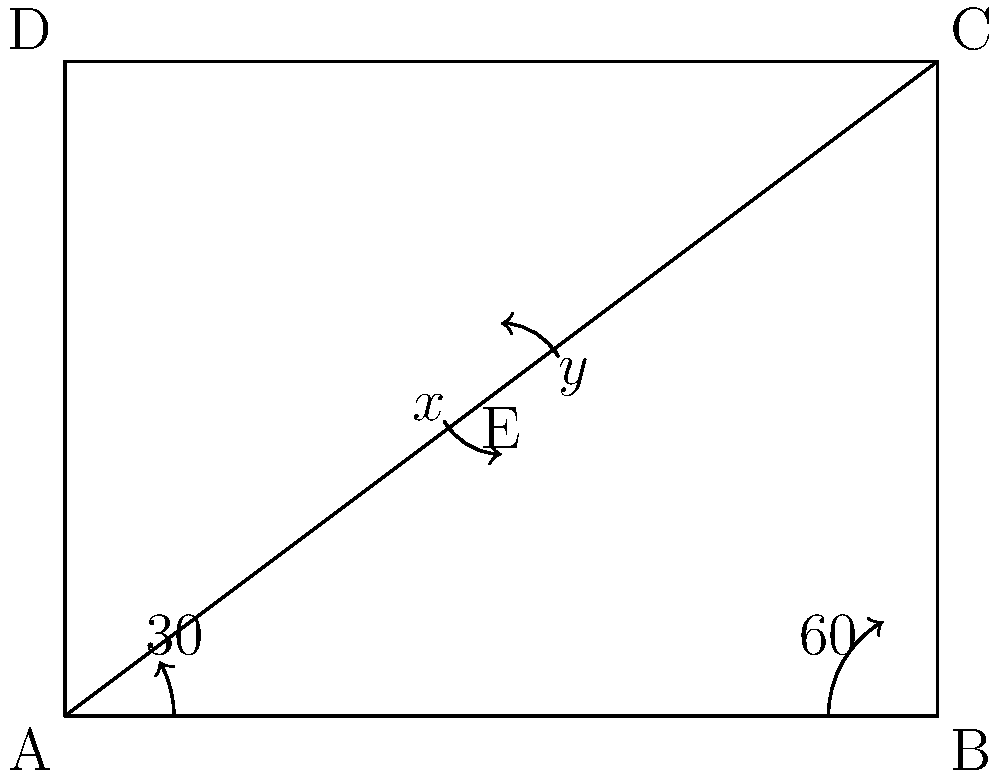During a tactical training exercise, you're positioned at point E in the diagram. Your lieutenant wants you to determine the relationship between angles x and y formed by your rifle's line of sight to different targets. Given that the angle at point A is 30° and the angle at point B is 60°, what can you conclude about angles x and y? Let's approach this step-by-step:

1) First, recall that the sum of angles in a triangle is always 180°.

2) In triangle ABE:
   $30° + 60° + x° = 180°$
   $90° + x° = 180°$
   $x° = 90°$

3) In triangle CDE:
   $y° + 90° = 180°$ (because angle AED is a right angle, as it's an alternate angle to the right angle at B)
   $y° = 90°$

4) Therefore, we can conclude that $x° = y° = 90°$

5) This means that angles x and y are congruent.

6) In terms of rifle positions, this implies that the angle formed by your line of sight to target A and target C is the same as the angle formed by your line of sight to target B and target D.
Answer: Angles x and y are congruent, both measuring 90°. 